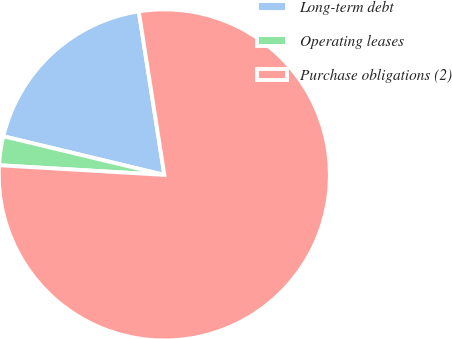<chart> <loc_0><loc_0><loc_500><loc_500><pie_chart><fcel>Long-term debt<fcel>Operating leases<fcel>Purchase obligations (2)<nl><fcel>18.78%<fcel>2.82%<fcel>78.4%<nl></chart> 